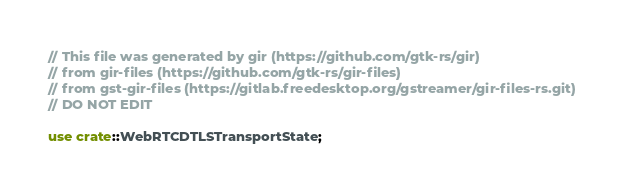Convert code to text. <code><loc_0><loc_0><loc_500><loc_500><_Rust_>// This file was generated by gir (https://github.com/gtk-rs/gir)
// from gir-files (https://github.com/gtk-rs/gir-files)
// from gst-gir-files (https://gitlab.freedesktop.org/gstreamer/gir-files-rs.git)
// DO NOT EDIT

use crate::WebRTCDTLSTransportState;</code> 